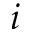<formula> <loc_0><loc_0><loc_500><loc_500>i</formula> 